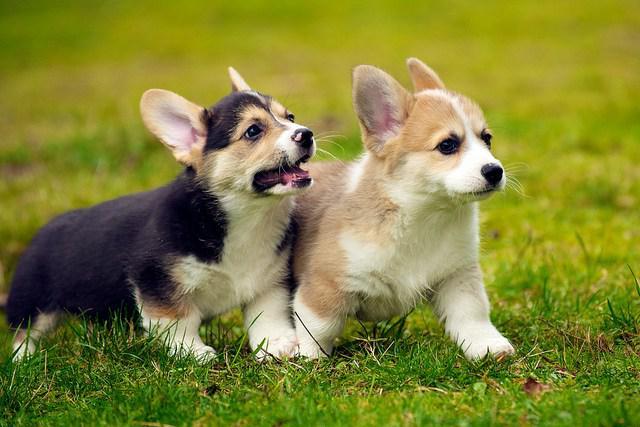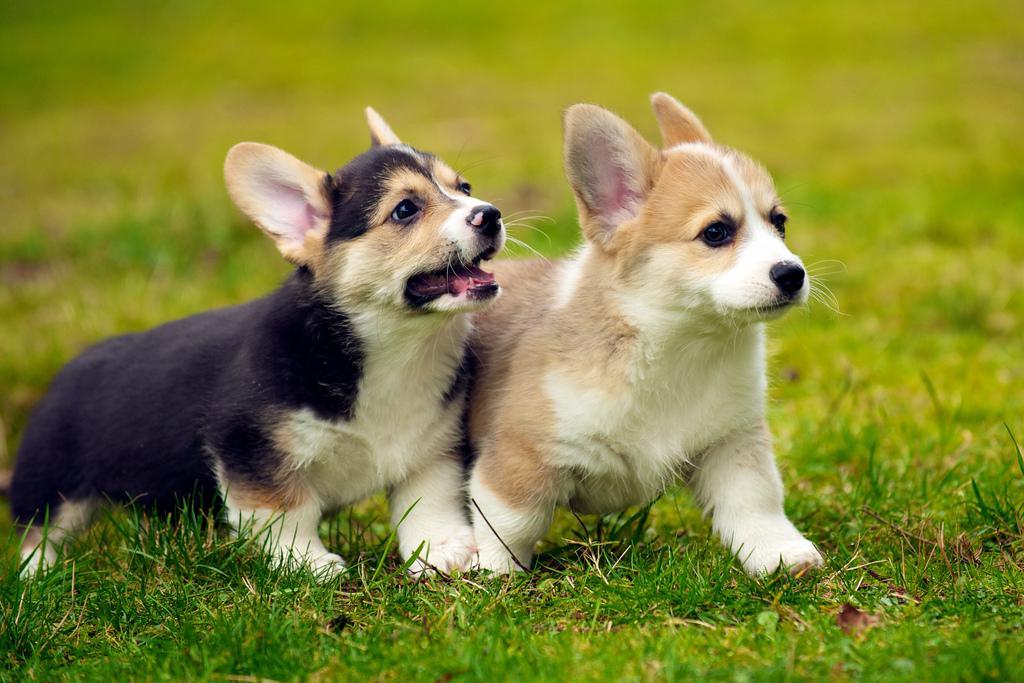The first image is the image on the left, the second image is the image on the right. Evaluate the accuracy of this statement regarding the images: "There are 3 dogs outdoors on the grass.". Is it true? Answer yes or no. No. The first image is the image on the left, the second image is the image on the right. For the images shown, is this caption "Three dogs are visible." true? Answer yes or no. No. 